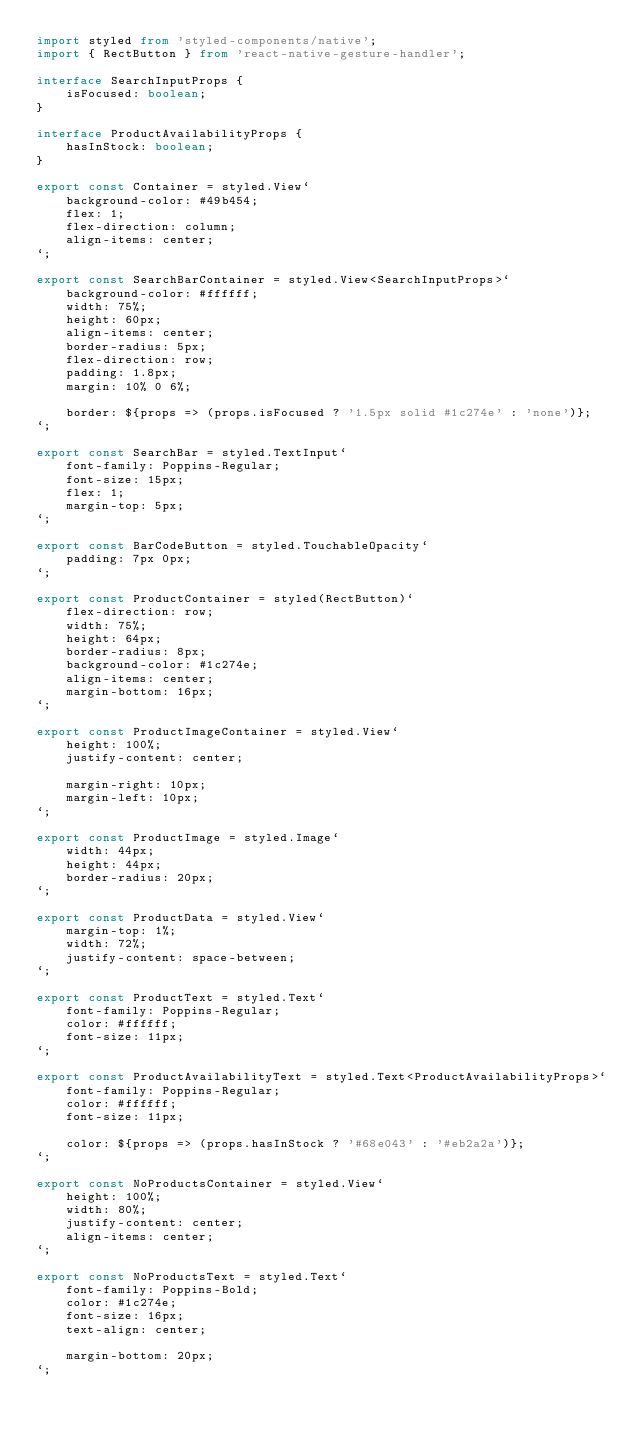<code> <loc_0><loc_0><loc_500><loc_500><_TypeScript_>import styled from 'styled-components/native';
import { RectButton } from 'react-native-gesture-handler';

interface SearchInputProps {
    isFocused: boolean;
}

interface ProductAvailabilityProps {
    hasInStock: boolean;
}

export const Container = styled.View`
    background-color: #49b454;
    flex: 1;
    flex-direction: column;
    align-items: center;
`;

export const SearchBarContainer = styled.View<SearchInputProps>`
    background-color: #ffffff;
    width: 75%;
    height: 60px;
    align-items: center;
    border-radius: 5px;
    flex-direction: row;
    padding: 1.8px;
    margin: 10% 0 6%;

    border: ${props => (props.isFocused ? '1.5px solid #1c274e' : 'none')};
`;

export const SearchBar = styled.TextInput`
    font-family: Poppins-Regular;
    font-size: 15px;
    flex: 1;
    margin-top: 5px;
`;

export const BarCodeButton = styled.TouchableOpacity`
    padding: 7px 0px;
`;

export const ProductContainer = styled(RectButton)`
    flex-direction: row;
    width: 75%;
    height: 64px;
    border-radius: 8px;
    background-color: #1c274e;
    align-items: center;
    margin-bottom: 16px;
`;

export const ProductImageContainer = styled.View`
    height: 100%;
    justify-content: center;

    margin-right: 10px;
    margin-left: 10px;
`;

export const ProductImage = styled.Image`
    width: 44px;
    height: 44px;
    border-radius: 20px;
`;

export const ProductData = styled.View`
    margin-top: 1%;
    width: 72%;
    justify-content: space-between;
`;

export const ProductText = styled.Text`
    font-family: Poppins-Regular;
    color: #ffffff;
    font-size: 11px;
`;

export const ProductAvailabilityText = styled.Text<ProductAvailabilityProps>`
    font-family: Poppins-Regular;
    color: #ffffff;
    font-size: 11px;

    color: ${props => (props.hasInStock ? '#68e043' : '#eb2a2a')};
`;

export const NoProductsContainer = styled.View`
    height: 100%;
    width: 80%;
    justify-content: center;
    align-items: center;
`;

export const NoProductsText = styled.Text`
    font-family: Poppins-Bold;
    color: #1c274e;
    font-size: 16px;
    text-align: center;

    margin-bottom: 20px;
`;
</code> 